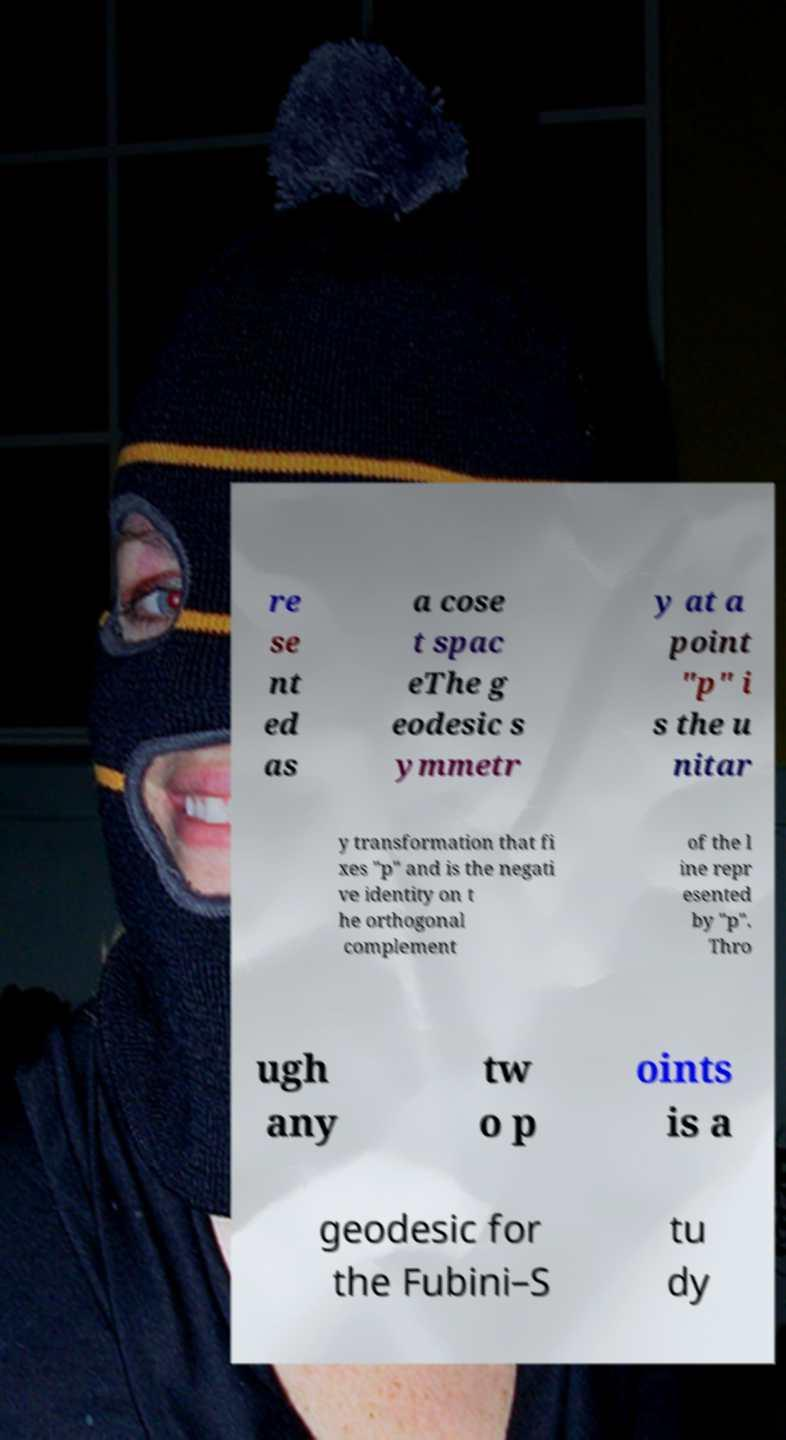There's text embedded in this image that I need extracted. Can you transcribe it verbatim? re se nt ed as a cose t spac eThe g eodesic s ymmetr y at a point "p" i s the u nitar y transformation that fi xes "p" and is the negati ve identity on t he orthogonal complement of the l ine repr esented by "p". Thro ugh any tw o p oints is a geodesic for the Fubini–S tu dy 